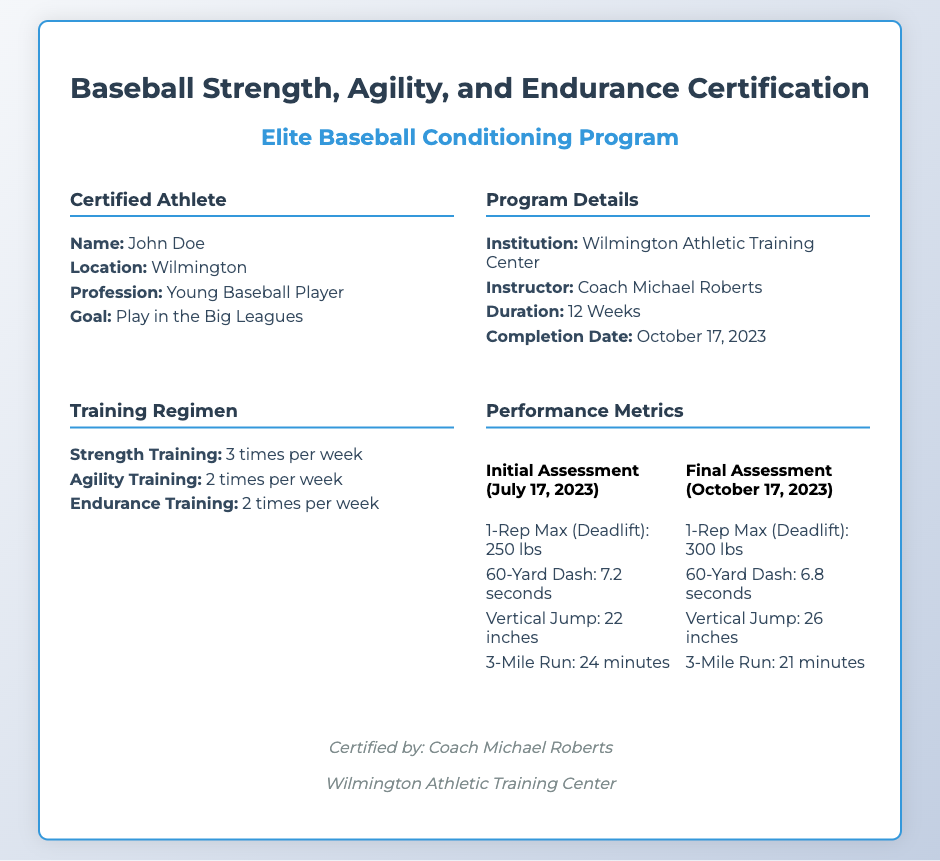what is the name of the certified athlete? The document states the certified athlete's name as John Doe.
Answer: John Doe who is the instructor of the program? The document mentions Coach Michael Roberts as the instructor.
Answer: Coach Michael Roberts what is the location of the training center? The training center is located in Wilmington, as specified in the document.
Answer: Wilmington how long is the duration of the program? The document indicates that the program lasts for 12 weeks.
Answer: 12 Weeks what was the 1-Rep Max (Deadlift) during the final assessment? According to the document, the final assessment showed a 1-Rep Max (Deadlift) of 300 lbs.
Answer: 300 lbs how much weight was added to the 1-Rep Max (Deadlift) from initial to final assessment? The increase in the 1-Rep Max (Deadlift) from initial to final assessment is calculated: 300 lbs - 250 lbs = 50 lbs.
Answer: 50 lbs how many times per week is strength training included in the regimen? The training regimen specifies strength training occurs 3 times per week.
Answer: 3 times per week when was the completion date of the program? The document lists the completion date as October 17, 2023.
Answer: October 17, 2023 what institution issued the certification? The certification was issued by the Wilmington Athletic Training Center.
Answer: Wilmington Athletic Training Center 